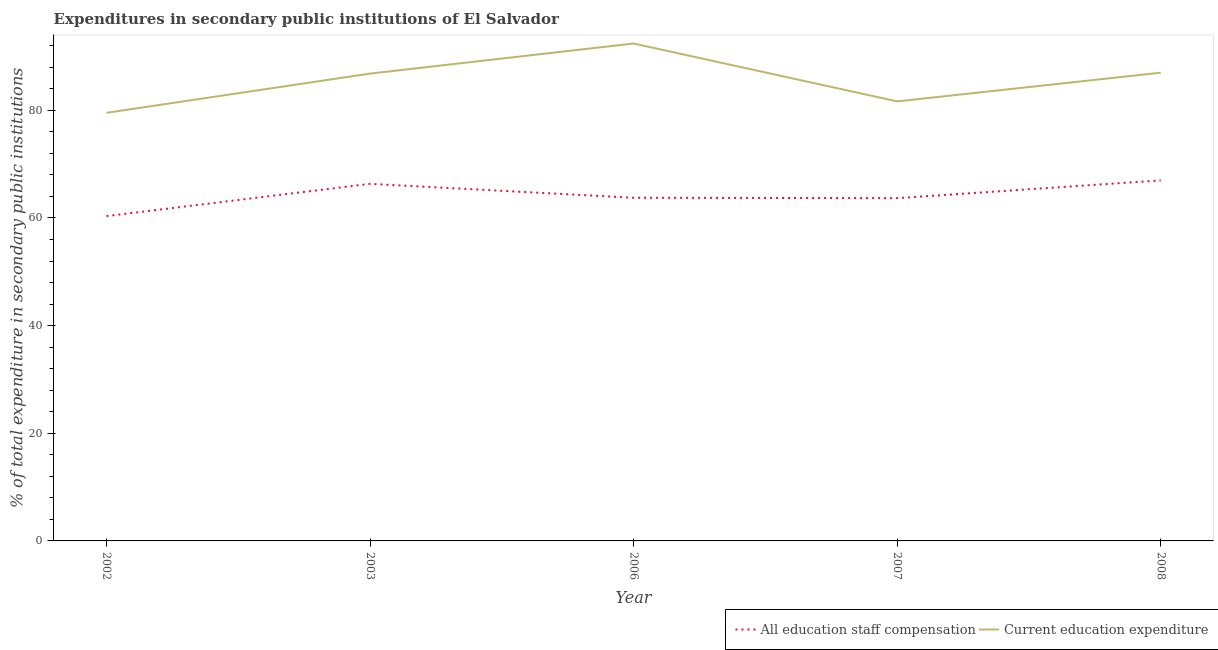How many different coloured lines are there?
Offer a very short reply. 2. Is the number of lines equal to the number of legend labels?
Make the answer very short. Yes. What is the expenditure in education in 2007?
Offer a very short reply. 81.65. Across all years, what is the maximum expenditure in education?
Your answer should be very brief. 92.4. Across all years, what is the minimum expenditure in staff compensation?
Give a very brief answer. 60.34. In which year was the expenditure in education minimum?
Offer a terse response. 2002. What is the total expenditure in education in the graph?
Make the answer very short. 427.38. What is the difference between the expenditure in education in 2002 and that in 2006?
Your answer should be compact. -12.88. What is the difference between the expenditure in education in 2003 and the expenditure in staff compensation in 2002?
Offer a very short reply. 26.47. What is the average expenditure in education per year?
Ensure brevity in your answer.  85.48. In the year 2007, what is the difference between the expenditure in staff compensation and expenditure in education?
Your answer should be very brief. -17.98. In how many years, is the expenditure in education greater than 28 %?
Offer a very short reply. 5. What is the ratio of the expenditure in staff compensation in 2002 to that in 2008?
Provide a short and direct response. 0.9. Is the expenditure in education in 2003 less than that in 2007?
Offer a very short reply. No. Is the difference between the expenditure in staff compensation in 2003 and 2007 greater than the difference between the expenditure in education in 2003 and 2007?
Your response must be concise. No. What is the difference between the highest and the second highest expenditure in education?
Your answer should be compact. 5.42. What is the difference between the highest and the lowest expenditure in staff compensation?
Your answer should be very brief. 6.64. In how many years, is the expenditure in education greater than the average expenditure in education taken over all years?
Ensure brevity in your answer.  3. Does the expenditure in staff compensation monotonically increase over the years?
Provide a succinct answer. No. How many lines are there?
Your response must be concise. 2. Are the values on the major ticks of Y-axis written in scientific E-notation?
Keep it short and to the point. No. How are the legend labels stacked?
Make the answer very short. Horizontal. What is the title of the graph?
Your response must be concise. Expenditures in secondary public institutions of El Salvador. Does "Revenue" appear as one of the legend labels in the graph?
Provide a succinct answer. No. What is the label or title of the X-axis?
Your answer should be compact. Year. What is the label or title of the Y-axis?
Your answer should be compact. % of total expenditure in secondary public institutions. What is the % of total expenditure in secondary public institutions in All education staff compensation in 2002?
Offer a very short reply. 60.34. What is the % of total expenditure in secondary public institutions of Current education expenditure in 2002?
Provide a short and direct response. 79.53. What is the % of total expenditure in secondary public institutions in All education staff compensation in 2003?
Your answer should be compact. 66.34. What is the % of total expenditure in secondary public institutions of Current education expenditure in 2003?
Offer a terse response. 86.81. What is the % of total expenditure in secondary public institutions of All education staff compensation in 2006?
Give a very brief answer. 63.75. What is the % of total expenditure in secondary public institutions in Current education expenditure in 2006?
Give a very brief answer. 92.4. What is the % of total expenditure in secondary public institutions of All education staff compensation in 2007?
Provide a short and direct response. 63.67. What is the % of total expenditure in secondary public institutions in Current education expenditure in 2007?
Ensure brevity in your answer.  81.65. What is the % of total expenditure in secondary public institutions of All education staff compensation in 2008?
Offer a very short reply. 66.98. What is the % of total expenditure in secondary public institutions in Current education expenditure in 2008?
Keep it short and to the point. 86.98. Across all years, what is the maximum % of total expenditure in secondary public institutions of All education staff compensation?
Your answer should be compact. 66.98. Across all years, what is the maximum % of total expenditure in secondary public institutions of Current education expenditure?
Offer a terse response. 92.4. Across all years, what is the minimum % of total expenditure in secondary public institutions in All education staff compensation?
Your response must be concise. 60.34. Across all years, what is the minimum % of total expenditure in secondary public institutions of Current education expenditure?
Your answer should be compact. 79.53. What is the total % of total expenditure in secondary public institutions in All education staff compensation in the graph?
Give a very brief answer. 321.08. What is the total % of total expenditure in secondary public institutions in Current education expenditure in the graph?
Your answer should be very brief. 427.38. What is the difference between the % of total expenditure in secondary public institutions in All education staff compensation in 2002 and that in 2003?
Provide a short and direct response. -6. What is the difference between the % of total expenditure in secondary public institutions in Current education expenditure in 2002 and that in 2003?
Ensure brevity in your answer.  -7.29. What is the difference between the % of total expenditure in secondary public institutions of All education staff compensation in 2002 and that in 2006?
Offer a very short reply. -3.41. What is the difference between the % of total expenditure in secondary public institutions of Current education expenditure in 2002 and that in 2006?
Make the answer very short. -12.88. What is the difference between the % of total expenditure in secondary public institutions in All education staff compensation in 2002 and that in 2007?
Provide a succinct answer. -3.33. What is the difference between the % of total expenditure in secondary public institutions in Current education expenditure in 2002 and that in 2007?
Provide a succinct answer. -2.12. What is the difference between the % of total expenditure in secondary public institutions in All education staff compensation in 2002 and that in 2008?
Make the answer very short. -6.64. What is the difference between the % of total expenditure in secondary public institutions of Current education expenditure in 2002 and that in 2008?
Offer a terse response. -7.46. What is the difference between the % of total expenditure in secondary public institutions in All education staff compensation in 2003 and that in 2006?
Offer a terse response. 2.59. What is the difference between the % of total expenditure in secondary public institutions of Current education expenditure in 2003 and that in 2006?
Your answer should be compact. -5.59. What is the difference between the % of total expenditure in secondary public institutions of All education staff compensation in 2003 and that in 2007?
Ensure brevity in your answer.  2.66. What is the difference between the % of total expenditure in secondary public institutions of Current education expenditure in 2003 and that in 2007?
Give a very brief answer. 5.16. What is the difference between the % of total expenditure in secondary public institutions in All education staff compensation in 2003 and that in 2008?
Your answer should be very brief. -0.64. What is the difference between the % of total expenditure in secondary public institutions of Current education expenditure in 2003 and that in 2008?
Make the answer very short. -0.17. What is the difference between the % of total expenditure in secondary public institutions of All education staff compensation in 2006 and that in 2007?
Keep it short and to the point. 0.07. What is the difference between the % of total expenditure in secondary public institutions in Current education expenditure in 2006 and that in 2007?
Give a very brief answer. 10.76. What is the difference between the % of total expenditure in secondary public institutions of All education staff compensation in 2006 and that in 2008?
Your response must be concise. -3.23. What is the difference between the % of total expenditure in secondary public institutions in Current education expenditure in 2006 and that in 2008?
Make the answer very short. 5.42. What is the difference between the % of total expenditure in secondary public institutions in All education staff compensation in 2007 and that in 2008?
Your response must be concise. -3.3. What is the difference between the % of total expenditure in secondary public institutions of Current education expenditure in 2007 and that in 2008?
Offer a very short reply. -5.34. What is the difference between the % of total expenditure in secondary public institutions of All education staff compensation in 2002 and the % of total expenditure in secondary public institutions of Current education expenditure in 2003?
Your answer should be compact. -26.47. What is the difference between the % of total expenditure in secondary public institutions in All education staff compensation in 2002 and the % of total expenditure in secondary public institutions in Current education expenditure in 2006?
Provide a succinct answer. -32.07. What is the difference between the % of total expenditure in secondary public institutions of All education staff compensation in 2002 and the % of total expenditure in secondary public institutions of Current education expenditure in 2007?
Give a very brief answer. -21.31. What is the difference between the % of total expenditure in secondary public institutions in All education staff compensation in 2002 and the % of total expenditure in secondary public institutions in Current education expenditure in 2008?
Offer a terse response. -26.65. What is the difference between the % of total expenditure in secondary public institutions in All education staff compensation in 2003 and the % of total expenditure in secondary public institutions in Current education expenditure in 2006?
Your response must be concise. -26.07. What is the difference between the % of total expenditure in secondary public institutions of All education staff compensation in 2003 and the % of total expenditure in secondary public institutions of Current education expenditure in 2007?
Offer a very short reply. -15.31. What is the difference between the % of total expenditure in secondary public institutions of All education staff compensation in 2003 and the % of total expenditure in secondary public institutions of Current education expenditure in 2008?
Make the answer very short. -20.65. What is the difference between the % of total expenditure in secondary public institutions in All education staff compensation in 2006 and the % of total expenditure in secondary public institutions in Current education expenditure in 2007?
Provide a succinct answer. -17.9. What is the difference between the % of total expenditure in secondary public institutions in All education staff compensation in 2006 and the % of total expenditure in secondary public institutions in Current education expenditure in 2008?
Your response must be concise. -23.24. What is the difference between the % of total expenditure in secondary public institutions in All education staff compensation in 2007 and the % of total expenditure in secondary public institutions in Current education expenditure in 2008?
Provide a succinct answer. -23.31. What is the average % of total expenditure in secondary public institutions of All education staff compensation per year?
Your answer should be compact. 64.22. What is the average % of total expenditure in secondary public institutions of Current education expenditure per year?
Give a very brief answer. 85.48. In the year 2002, what is the difference between the % of total expenditure in secondary public institutions of All education staff compensation and % of total expenditure in secondary public institutions of Current education expenditure?
Offer a terse response. -19.19. In the year 2003, what is the difference between the % of total expenditure in secondary public institutions of All education staff compensation and % of total expenditure in secondary public institutions of Current education expenditure?
Keep it short and to the point. -20.48. In the year 2006, what is the difference between the % of total expenditure in secondary public institutions of All education staff compensation and % of total expenditure in secondary public institutions of Current education expenditure?
Ensure brevity in your answer.  -28.66. In the year 2007, what is the difference between the % of total expenditure in secondary public institutions in All education staff compensation and % of total expenditure in secondary public institutions in Current education expenditure?
Offer a very short reply. -17.98. In the year 2008, what is the difference between the % of total expenditure in secondary public institutions in All education staff compensation and % of total expenditure in secondary public institutions in Current education expenditure?
Keep it short and to the point. -20.01. What is the ratio of the % of total expenditure in secondary public institutions in All education staff compensation in 2002 to that in 2003?
Your response must be concise. 0.91. What is the ratio of the % of total expenditure in secondary public institutions in Current education expenditure in 2002 to that in 2003?
Ensure brevity in your answer.  0.92. What is the ratio of the % of total expenditure in secondary public institutions of All education staff compensation in 2002 to that in 2006?
Provide a succinct answer. 0.95. What is the ratio of the % of total expenditure in secondary public institutions of Current education expenditure in 2002 to that in 2006?
Ensure brevity in your answer.  0.86. What is the ratio of the % of total expenditure in secondary public institutions in All education staff compensation in 2002 to that in 2007?
Ensure brevity in your answer.  0.95. What is the ratio of the % of total expenditure in secondary public institutions in Current education expenditure in 2002 to that in 2007?
Give a very brief answer. 0.97. What is the ratio of the % of total expenditure in secondary public institutions in All education staff compensation in 2002 to that in 2008?
Keep it short and to the point. 0.9. What is the ratio of the % of total expenditure in secondary public institutions in Current education expenditure in 2002 to that in 2008?
Your answer should be very brief. 0.91. What is the ratio of the % of total expenditure in secondary public institutions of All education staff compensation in 2003 to that in 2006?
Give a very brief answer. 1.04. What is the ratio of the % of total expenditure in secondary public institutions of Current education expenditure in 2003 to that in 2006?
Keep it short and to the point. 0.94. What is the ratio of the % of total expenditure in secondary public institutions of All education staff compensation in 2003 to that in 2007?
Your answer should be very brief. 1.04. What is the ratio of the % of total expenditure in secondary public institutions of Current education expenditure in 2003 to that in 2007?
Your answer should be compact. 1.06. What is the ratio of the % of total expenditure in secondary public institutions in Current education expenditure in 2003 to that in 2008?
Ensure brevity in your answer.  1. What is the ratio of the % of total expenditure in secondary public institutions in All education staff compensation in 2006 to that in 2007?
Offer a terse response. 1. What is the ratio of the % of total expenditure in secondary public institutions of Current education expenditure in 2006 to that in 2007?
Your response must be concise. 1.13. What is the ratio of the % of total expenditure in secondary public institutions of All education staff compensation in 2006 to that in 2008?
Make the answer very short. 0.95. What is the ratio of the % of total expenditure in secondary public institutions in Current education expenditure in 2006 to that in 2008?
Your answer should be compact. 1.06. What is the ratio of the % of total expenditure in secondary public institutions of All education staff compensation in 2007 to that in 2008?
Your response must be concise. 0.95. What is the ratio of the % of total expenditure in secondary public institutions of Current education expenditure in 2007 to that in 2008?
Ensure brevity in your answer.  0.94. What is the difference between the highest and the second highest % of total expenditure in secondary public institutions of All education staff compensation?
Offer a very short reply. 0.64. What is the difference between the highest and the second highest % of total expenditure in secondary public institutions in Current education expenditure?
Your answer should be very brief. 5.42. What is the difference between the highest and the lowest % of total expenditure in secondary public institutions of All education staff compensation?
Your response must be concise. 6.64. What is the difference between the highest and the lowest % of total expenditure in secondary public institutions of Current education expenditure?
Ensure brevity in your answer.  12.88. 